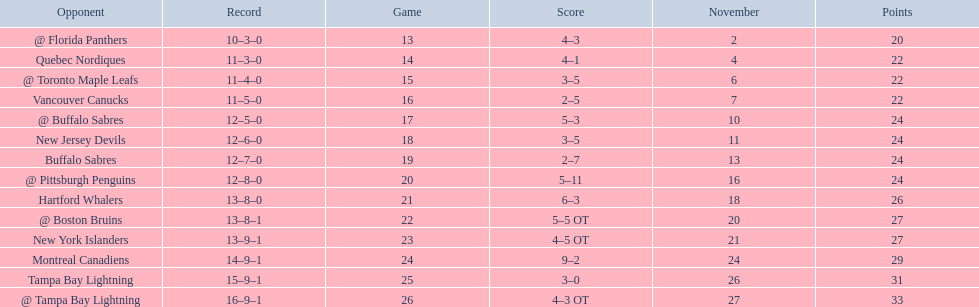Who did the philadelphia flyers play in game 17? @ Buffalo Sabres. What was the score of the november 10th game against the buffalo sabres? 5–3. Which team in the atlantic division had less points than the philadelphia flyers? Tampa Bay Lightning. 